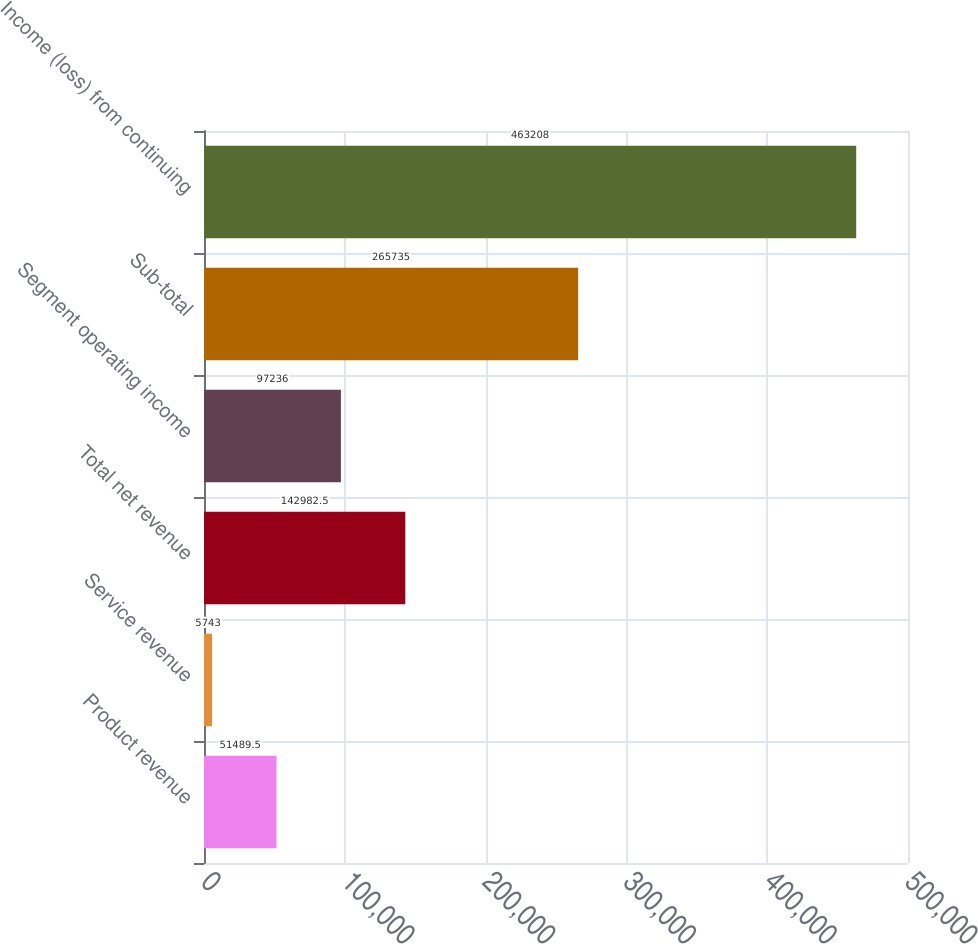Convert chart. <chart><loc_0><loc_0><loc_500><loc_500><bar_chart><fcel>Product revenue<fcel>Service revenue<fcel>Total net revenue<fcel>Segment operating income<fcel>Sub-total<fcel>Income (loss) from continuing<nl><fcel>51489.5<fcel>5743<fcel>142982<fcel>97236<fcel>265735<fcel>463208<nl></chart> 